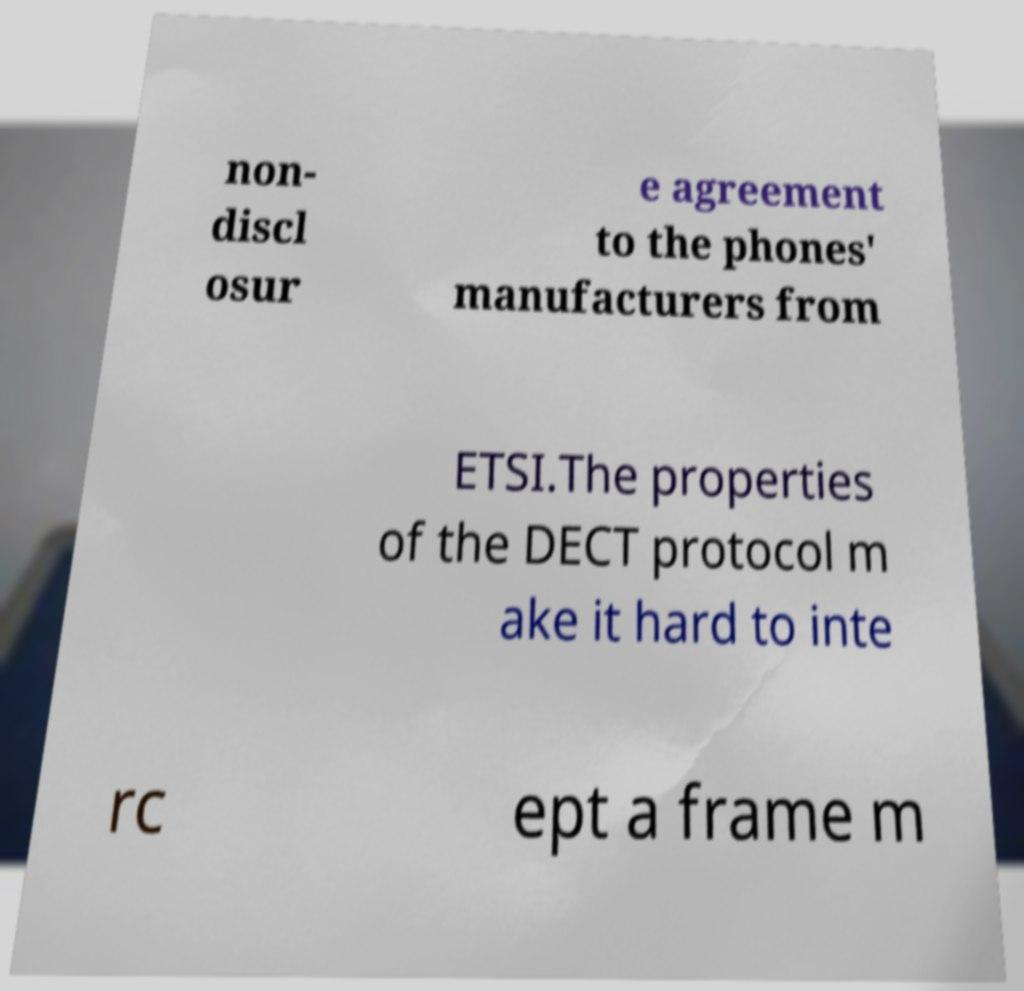Please identify and transcribe the text found in this image. non- discl osur e agreement to the phones' manufacturers from ETSI.The properties of the DECT protocol m ake it hard to inte rc ept a frame m 